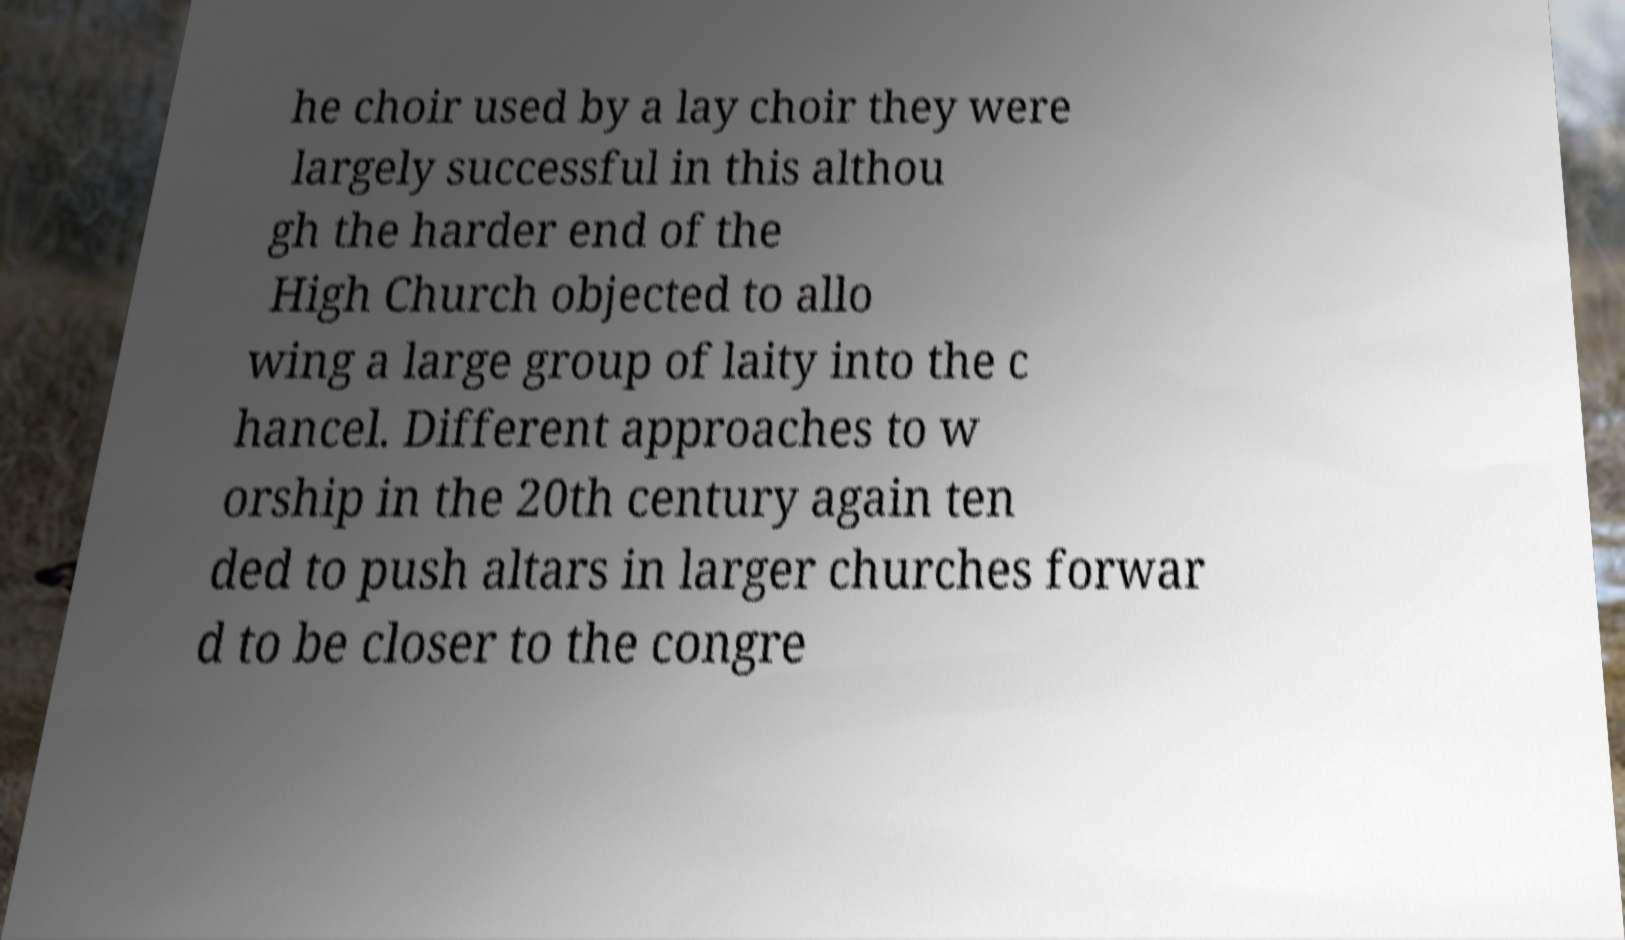Could you assist in decoding the text presented in this image and type it out clearly? he choir used by a lay choir they were largely successful in this althou gh the harder end of the High Church objected to allo wing a large group of laity into the c hancel. Different approaches to w orship in the 20th century again ten ded to push altars in larger churches forwar d to be closer to the congre 